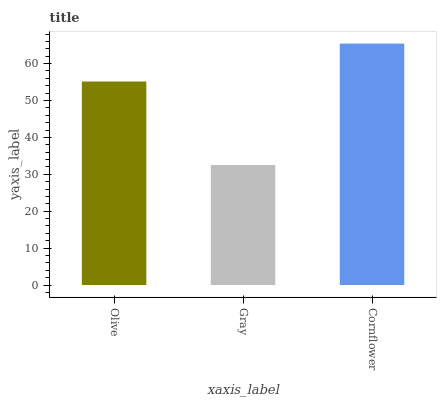Is Cornflower the minimum?
Answer yes or no. No. Is Gray the maximum?
Answer yes or no. No. Is Cornflower greater than Gray?
Answer yes or no. Yes. Is Gray less than Cornflower?
Answer yes or no. Yes. Is Gray greater than Cornflower?
Answer yes or no. No. Is Cornflower less than Gray?
Answer yes or no. No. Is Olive the high median?
Answer yes or no. Yes. Is Olive the low median?
Answer yes or no. Yes. Is Gray the high median?
Answer yes or no. No. Is Gray the low median?
Answer yes or no. No. 